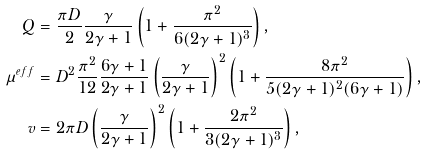<formula> <loc_0><loc_0><loc_500><loc_500>Q & = \frac { \pi D } { 2 } \frac { \gamma } { 2 \gamma + 1 } \left ( 1 + \frac { \pi ^ { 2 } } { 6 ( 2 \gamma + 1 ) ^ { 3 } } \right ) , \\ \mu ^ { e f f } & = D ^ { 2 } \frac { \pi ^ { 2 } } { 1 2 } \frac { 6 \gamma + 1 } { 2 \gamma + 1 } \left ( \frac { \gamma } { 2 \gamma + 1 } \right ) ^ { 2 } \left ( 1 + \frac { 8 \pi ^ { 2 } } { 5 ( 2 \gamma + 1 ) ^ { 2 } ( 6 \gamma + 1 ) } \right ) , \\ v & = 2 \pi D \left ( \frac { \gamma } { 2 \gamma + 1 } \right ) ^ { 2 } \left ( 1 + \frac { 2 \pi ^ { 2 } } { 3 ( 2 \gamma + 1 ) ^ { 3 } } \right ) ,</formula> 